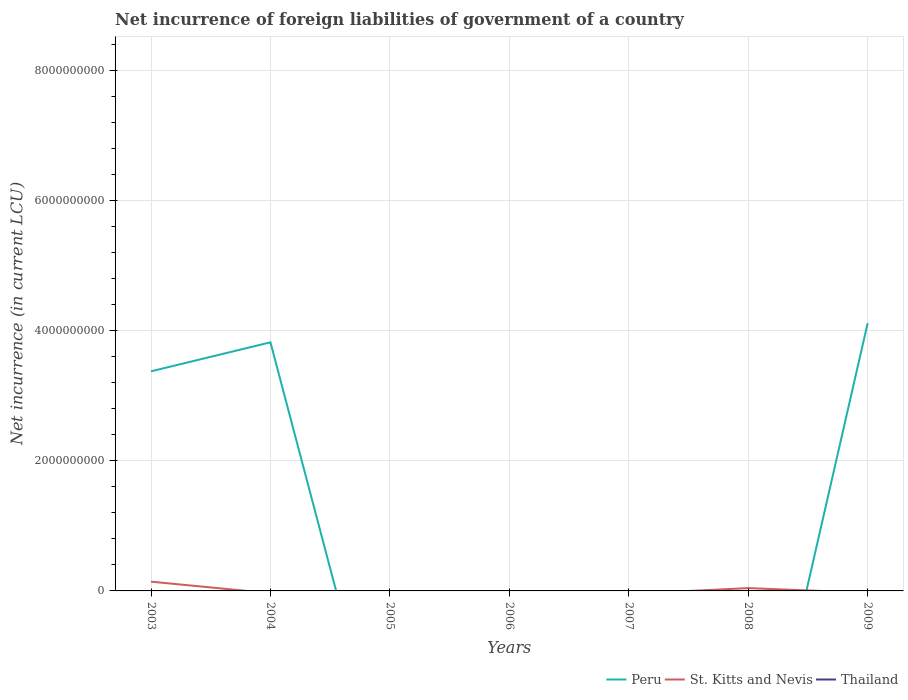How many different coloured lines are there?
Your answer should be compact. 2. Across all years, what is the maximum net incurrence of foreign liabilities in Thailand?
Keep it short and to the point. 0. What is the difference between the highest and the second highest net incurrence of foreign liabilities in St. Kitts and Nevis?
Give a very brief answer. 1.42e+08. Are the values on the major ticks of Y-axis written in scientific E-notation?
Keep it short and to the point. No. Does the graph contain any zero values?
Your answer should be compact. Yes. What is the title of the graph?
Give a very brief answer. Net incurrence of foreign liabilities of government of a country. What is the label or title of the Y-axis?
Offer a very short reply. Net incurrence (in current LCU). What is the Net incurrence (in current LCU) in Peru in 2003?
Provide a succinct answer. 3.38e+09. What is the Net incurrence (in current LCU) in St. Kitts and Nevis in 2003?
Offer a very short reply. 1.42e+08. What is the Net incurrence (in current LCU) in Thailand in 2003?
Ensure brevity in your answer.  0. What is the Net incurrence (in current LCU) in Peru in 2004?
Give a very brief answer. 3.82e+09. What is the Net incurrence (in current LCU) of Thailand in 2004?
Your answer should be compact. 0. What is the Net incurrence (in current LCU) in St. Kitts and Nevis in 2005?
Offer a very short reply. 0. What is the Net incurrence (in current LCU) of Thailand in 2005?
Ensure brevity in your answer.  0. What is the Net incurrence (in current LCU) of Peru in 2006?
Your answer should be very brief. 0. What is the Net incurrence (in current LCU) of St. Kitts and Nevis in 2006?
Your answer should be very brief. 0. What is the Net incurrence (in current LCU) in Thailand in 2007?
Give a very brief answer. 0. What is the Net incurrence (in current LCU) of Peru in 2008?
Your answer should be compact. 0. What is the Net incurrence (in current LCU) in St. Kitts and Nevis in 2008?
Offer a very short reply. 4.33e+07. What is the Net incurrence (in current LCU) of Thailand in 2008?
Your response must be concise. 0. What is the Net incurrence (in current LCU) of Peru in 2009?
Your answer should be compact. 4.12e+09. What is the Net incurrence (in current LCU) in St. Kitts and Nevis in 2009?
Your answer should be very brief. 0. What is the Net incurrence (in current LCU) in Thailand in 2009?
Offer a terse response. 0. Across all years, what is the maximum Net incurrence (in current LCU) of Peru?
Offer a terse response. 4.12e+09. Across all years, what is the maximum Net incurrence (in current LCU) of St. Kitts and Nevis?
Ensure brevity in your answer.  1.42e+08. Across all years, what is the minimum Net incurrence (in current LCU) in St. Kitts and Nevis?
Make the answer very short. 0. What is the total Net incurrence (in current LCU) in Peru in the graph?
Your response must be concise. 1.13e+1. What is the total Net incurrence (in current LCU) of St. Kitts and Nevis in the graph?
Make the answer very short. 1.86e+08. What is the difference between the Net incurrence (in current LCU) of Peru in 2003 and that in 2004?
Make the answer very short. -4.46e+08. What is the difference between the Net incurrence (in current LCU) of St. Kitts and Nevis in 2003 and that in 2008?
Offer a terse response. 9.90e+07. What is the difference between the Net incurrence (in current LCU) in Peru in 2003 and that in 2009?
Make the answer very short. -7.41e+08. What is the difference between the Net incurrence (in current LCU) of Peru in 2004 and that in 2009?
Your answer should be very brief. -2.95e+08. What is the difference between the Net incurrence (in current LCU) of Peru in 2003 and the Net incurrence (in current LCU) of St. Kitts and Nevis in 2008?
Offer a very short reply. 3.33e+09. What is the difference between the Net incurrence (in current LCU) in Peru in 2004 and the Net incurrence (in current LCU) in St. Kitts and Nevis in 2008?
Your answer should be compact. 3.78e+09. What is the average Net incurrence (in current LCU) in Peru per year?
Your response must be concise. 1.62e+09. What is the average Net incurrence (in current LCU) of St. Kitts and Nevis per year?
Your response must be concise. 2.65e+07. In the year 2003, what is the difference between the Net incurrence (in current LCU) of Peru and Net incurrence (in current LCU) of St. Kitts and Nevis?
Your response must be concise. 3.24e+09. What is the ratio of the Net incurrence (in current LCU) in Peru in 2003 to that in 2004?
Your answer should be compact. 0.88. What is the ratio of the Net incurrence (in current LCU) of St. Kitts and Nevis in 2003 to that in 2008?
Your answer should be very brief. 3.29. What is the ratio of the Net incurrence (in current LCU) of Peru in 2003 to that in 2009?
Offer a terse response. 0.82. What is the ratio of the Net incurrence (in current LCU) in Peru in 2004 to that in 2009?
Ensure brevity in your answer.  0.93. What is the difference between the highest and the second highest Net incurrence (in current LCU) in Peru?
Provide a short and direct response. 2.95e+08. What is the difference between the highest and the lowest Net incurrence (in current LCU) of Peru?
Provide a short and direct response. 4.12e+09. What is the difference between the highest and the lowest Net incurrence (in current LCU) of St. Kitts and Nevis?
Give a very brief answer. 1.42e+08. 